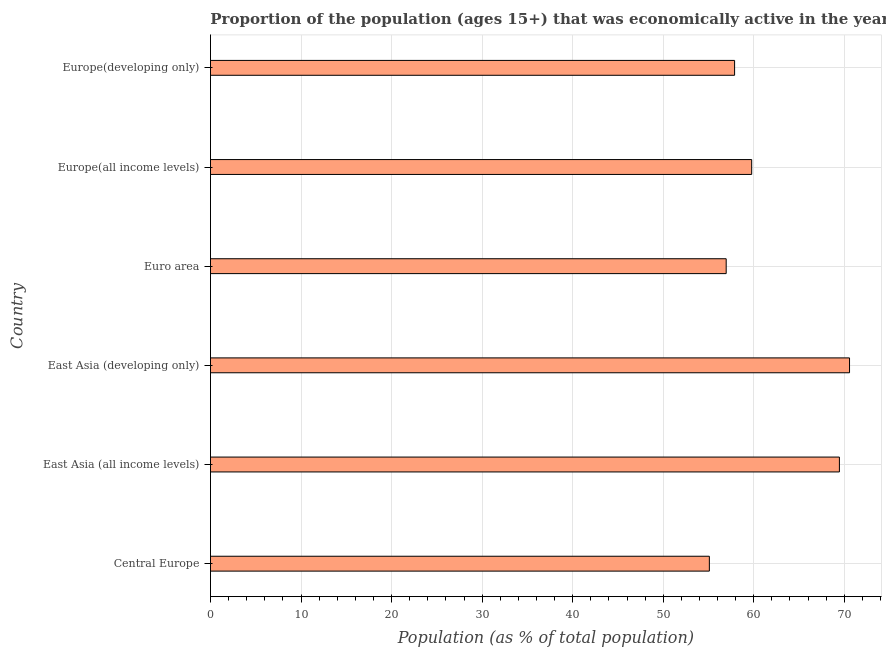Does the graph contain grids?
Offer a very short reply. Yes. What is the title of the graph?
Give a very brief answer. Proportion of the population (ages 15+) that was economically active in the year 2011. What is the label or title of the X-axis?
Offer a terse response. Population (as % of total population). What is the label or title of the Y-axis?
Give a very brief answer. Country. What is the percentage of economically active population in Central Europe?
Offer a terse response. 55.1. Across all countries, what is the maximum percentage of economically active population?
Offer a terse response. 70.58. Across all countries, what is the minimum percentage of economically active population?
Make the answer very short. 55.1. In which country was the percentage of economically active population maximum?
Provide a succinct answer. East Asia (developing only). In which country was the percentage of economically active population minimum?
Offer a terse response. Central Europe. What is the sum of the percentage of economically active population?
Make the answer very short. 369.74. What is the difference between the percentage of economically active population in East Asia (developing only) and Europe(all income levels)?
Offer a very short reply. 10.81. What is the average percentage of economically active population per country?
Offer a terse response. 61.62. What is the median percentage of economically active population?
Offer a terse response. 58.83. In how many countries, is the percentage of economically active population greater than 50 %?
Provide a succinct answer. 6. What is the ratio of the percentage of economically active population in East Asia (developing only) to that in Europe(all income levels)?
Ensure brevity in your answer.  1.18. Is the percentage of economically active population in East Asia (all income levels) less than that in Europe(developing only)?
Your response must be concise. No. Is the difference between the percentage of economically active population in East Asia (all income levels) and Euro area greater than the difference between any two countries?
Offer a very short reply. No. What is the difference between the highest and the second highest percentage of economically active population?
Provide a succinct answer. 1.12. What is the difference between the highest and the lowest percentage of economically active population?
Provide a succinct answer. 15.48. Are all the bars in the graph horizontal?
Ensure brevity in your answer.  Yes. How many countries are there in the graph?
Offer a terse response. 6. What is the difference between two consecutive major ticks on the X-axis?
Make the answer very short. 10. What is the Population (as % of total population) in Central Europe?
Offer a very short reply. 55.1. What is the Population (as % of total population) of East Asia (all income levels)?
Provide a succinct answer. 69.46. What is the Population (as % of total population) in East Asia (developing only)?
Give a very brief answer. 70.58. What is the Population (as % of total population) of Euro area?
Your response must be concise. 56.95. What is the Population (as % of total population) in Europe(all income levels)?
Your answer should be very brief. 59.77. What is the Population (as % of total population) of Europe(developing only)?
Ensure brevity in your answer.  57.88. What is the difference between the Population (as % of total population) in Central Europe and East Asia (all income levels)?
Provide a short and direct response. -14.36. What is the difference between the Population (as % of total population) in Central Europe and East Asia (developing only)?
Make the answer very short. -15.48. What is the difference between the Population (as % of total population) in Central Europe and Euro area?
Your answer should be very brief. -1.86. What is the difference between the Population (as % of total population) in Central Europe and Europe(all income levels)?
Make the answer very short. -4.67. What is the difference between the Population (as % of total population) in Central Europe and Europe(developing only)?
Provide a succinct answer. -2.79. What is the difference between the Population (as % of total population) in East Asia (all income levels) and East Asia (developing only)?
Provide a short and direct response. -1.12. What is the difference between the Population (as % of total population) in East Asia (all income levels) and Euro area?
Ensure brevity in your answer.  12.5. What is the difference between the Population (as % of total population) in East Asia (all income levels) and Europe(all income levels)?
Offer a terse response. 9.69. What is the difference between the Population (as % of total population) in East Asia (all income levels) and Europe(developing only)?
Offer a terse response. 11.57. What is the difference between the Population (as % of total population) in East Asia (developing only) and Euro area?
Offer a very short reply. 13.62. What is the difference between the Population (as % of total population) in East Asia (developing only) and Europe(all income levels)?
Your answer should be compact. 10.81. What is the difference between the Population (as % of total population) in East Asia (developing only) and Europe(developing only)?
Your answer should be very brief. 12.69. What is the difference between the Population (as % of total population) in Euro area and Europe(all income levels)?
Provide a short and direct response. -2.82. What is the difference between the Population (as % of total population) in Euro area and Europe(developing only)?
Give a very brief answer. -0.93. What is the difference between the Population (as % of total population) in Europe(all income levels) and Europe(developing only)?
Offer a terse response. 1.89. What is the ratio of the Population (as % of total population) in Central Europe to that in East Asia (all income levels)?
Your answer should be compact. 0.79. What is the ratio of the Population (as % of total population) in Central Europe to that in East Asia (developing only)?
Give a very brief answer. 0.78. What is the ratio of the Population (as % of total population) in Central Europe to that in Europe(all income levels)?
Offer a very short reply. 0.92. What is the ratio of the Population (as % of total population) in East Asia (all income levels) to that in Euro area?
Ensure brevity in your answer.  1.22. What is the ratio of the Population (as % of total population) in East Asia (all income levels) to that in Europe(all income levels)?
Offer a very short reply. 1.16. What is the ratio of the Population (as % of total population) in East Asia (developing only) to that in Euro area?
Provide a succinct answer. 1.24. What is the ratio of the Population (as % of total population) in East Asia (developing only) to that in Europe(all income levels)?
Offer a terse response. 1.18. What is the ratio of the Population (as % of total population) in East Asia (developing only) to that in Europe(developing only)?
Your answer should be very brief. 1.22. What is the ratio of the Population (as % of total population) in Euro area to that in Europe(all income levels)?
Give a very brief answer. 0.95. What is the ratio of the Population (as % of total population) in Euro area to that in Europe(developing only)?
Provide a short and direct response. 0.98. What is the ratio of the Population (as % of total population) in Europe(all income levels) to that in Europe(developing only)?
Make the answer very short. 1.03. 